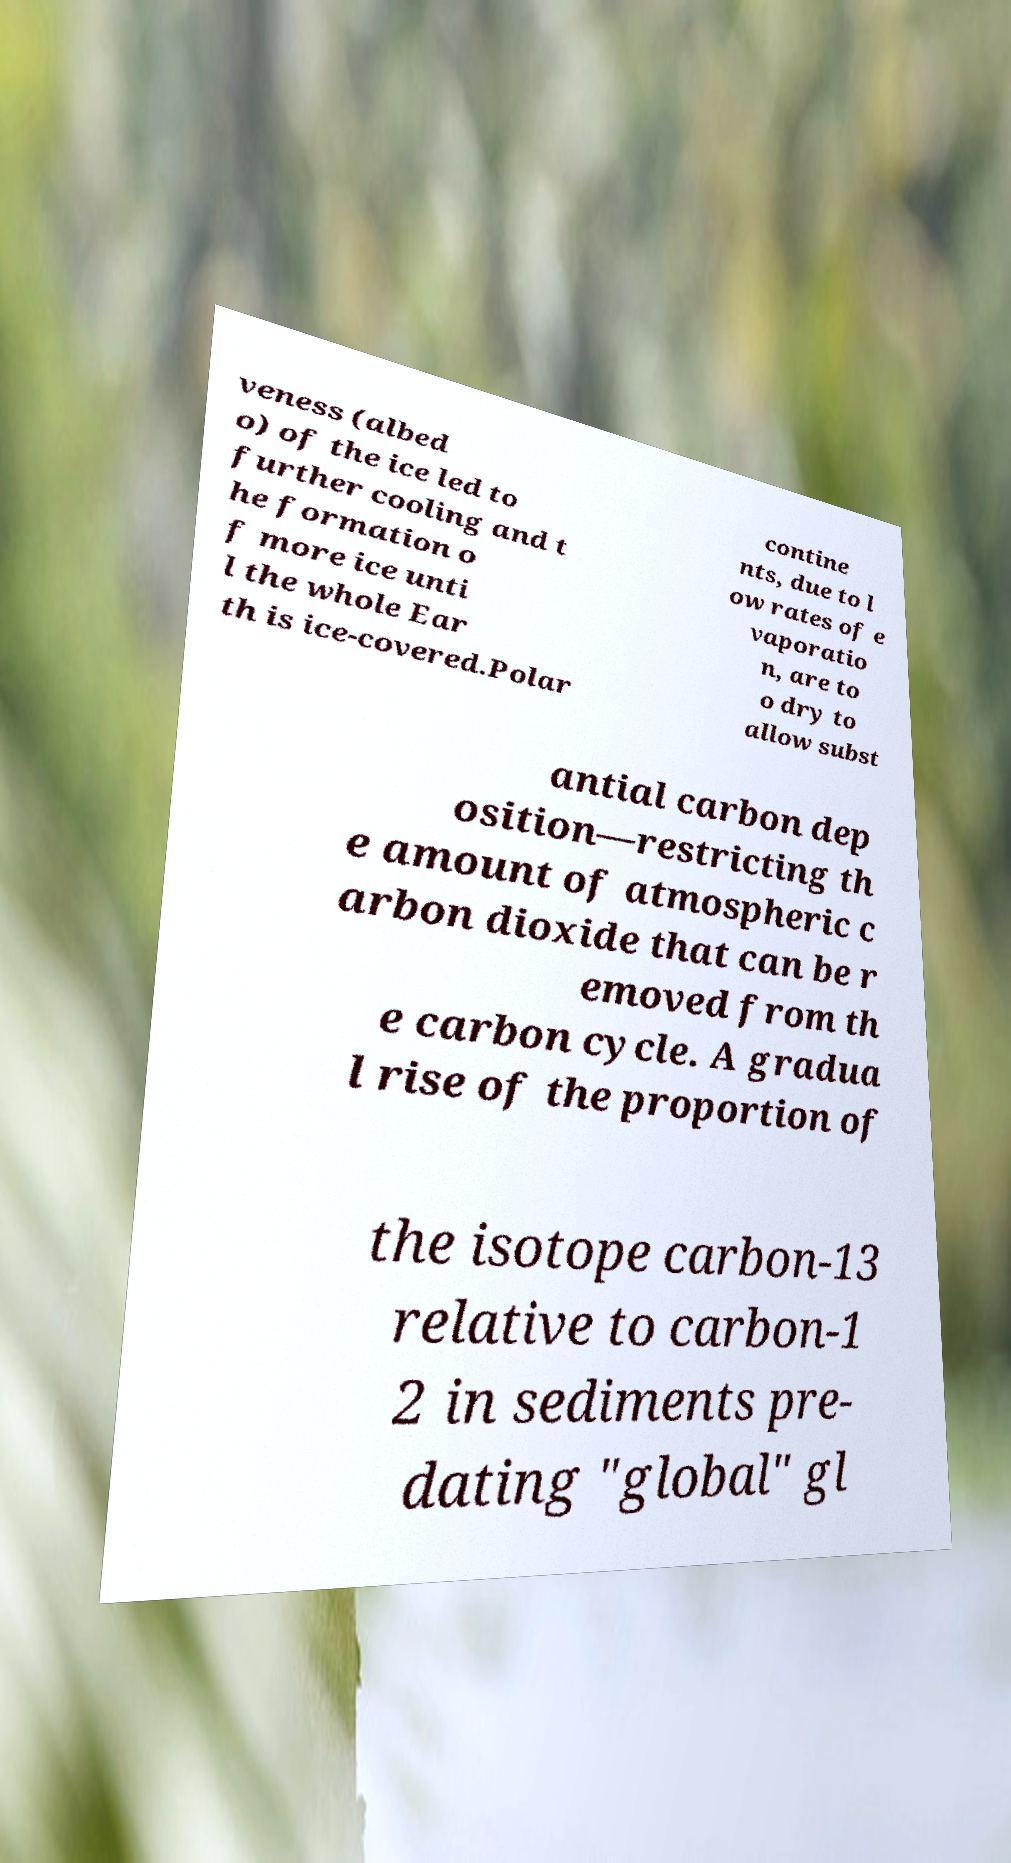Could you extract and type out the text from this image? veness (albed o) of the ice led to further cooling and t he formation o f more ice unti l the whole Ear th is ice-covered.Polar contine nts, due to l ow rates of e vaporatio n, are to o dry to allow subst antial carbon dep osition—restricting th e amount of atmospheric c arbon dioxide that can be r emoved from th e carbon cycle. A gradua l rise of the proportion of the isotope carbon-13 relative to carbon-1 2 in sediments pre- dating "global" gl 